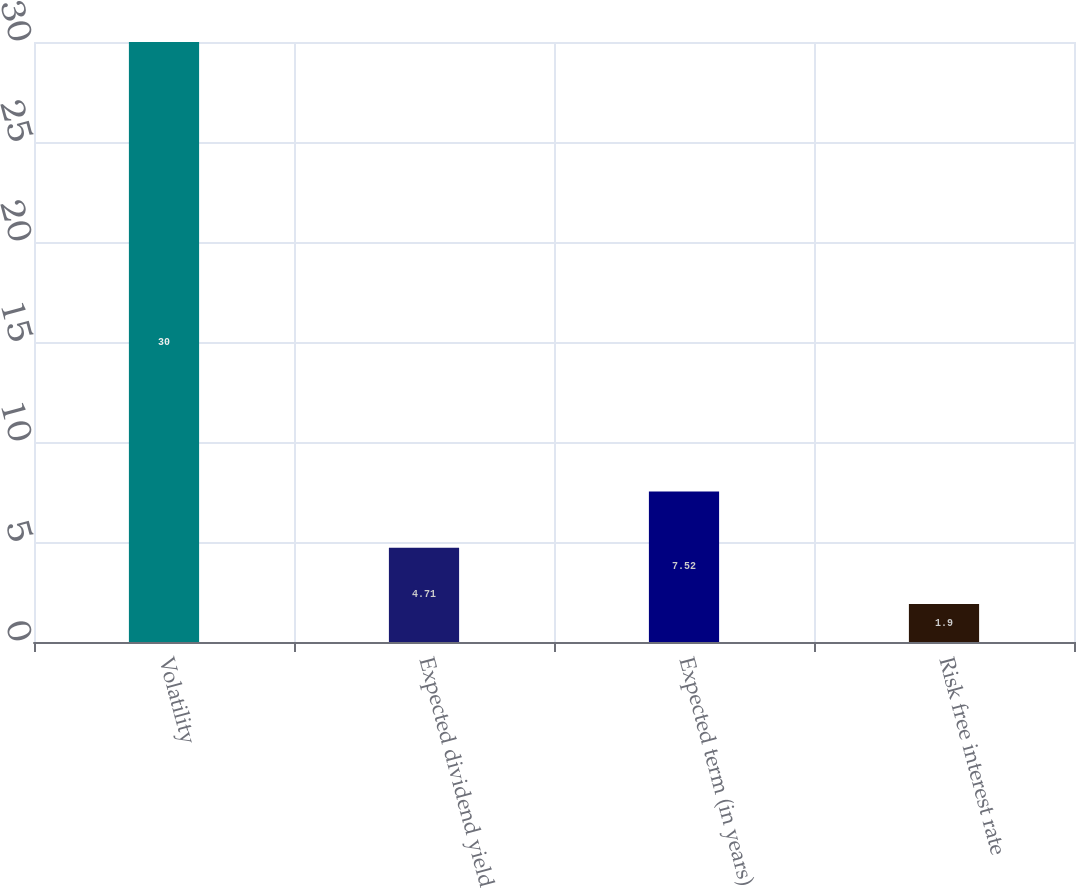Convert chart. <chart><loc_0><loc_0><loc_500><loc_500><bar_chart><fcel>Volatility<fcel>Expected dividend yield<fcel>Expected term (in years)<fcel>Risk free interest rate<nl><fcel>30<fcel>4.71<fcel>7.52<fcel>1.9<nl></chart> 